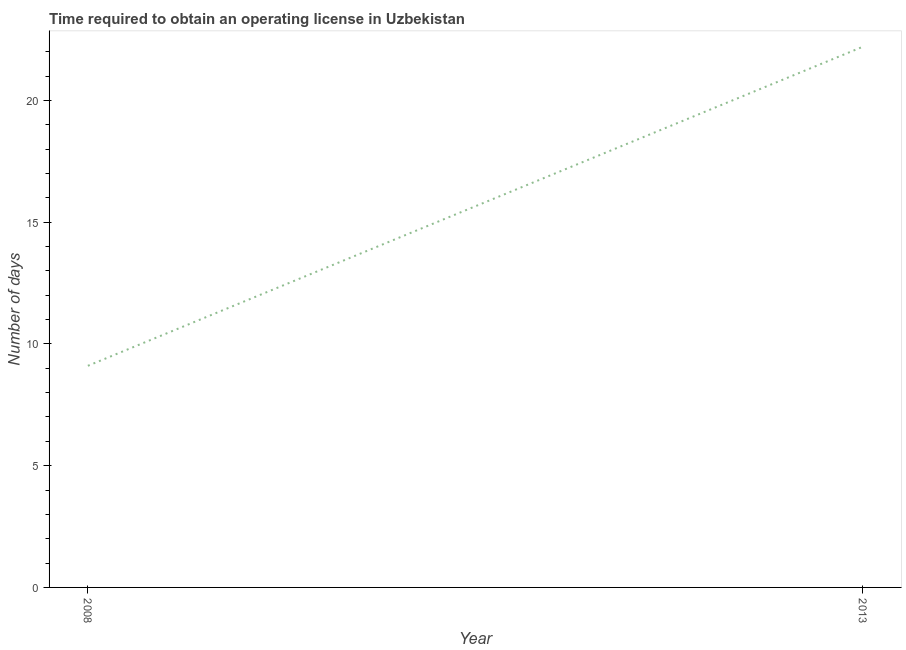What is the number of days to obtain operating license in 2008?
Offer a terse response. 9.1. Across all years, what is the maximum number of days to obtain operating license?
Your answer should be compact. 22.2. What is the sum of the number of days to obtain operating license?
Offer a terse response. 31.3. What is the difference between the number of days to obtain operating license in 2008 and 2013?
Offer a terse response. -13.1. What is the average number of days to obtain operating license per year?
Offer a very short reply. 15.65. What is the median number of days to obtain operating license?
Make the answer very short. 15.65. In how many years, is the number of days to obtain operating license greater than 4 days?
Keep it short and to the point. 2. Do a majority of the years between 2013 and 2008 (inclusive) have number of days to obtain operating license greater than 7 days?
Give a very brief answer. No. What is the ratio of the number of days to obtain operating license in 2008 to that in 2013?
Your answer should be very brief. 0.41. In how many years, is the number of days to obtain operating license greater than the average number of days to obtain operating license taken over all years?
Offer a very short reply. 1. Does the number of days to obtain operating license monotonically increase over the years?
Ensure brevity in your answer.  Yes. What is the difference between two consecutive major ticks on the Y-axis?
Offer a very short reply. 5. Are the values on the major ticks of Y-axis written in scientific E-notation?
Provide a short and direct response. No. Does the graph contain grids?
Your response must be concise. No. What is the title of the graph?
Give a very brief answer. Time required to obtain an operating license in Uzbekistan. What is the label or title of the X-axis?
Your answer should be very brief. Year. What is the label or title of the Y-axis?
Provide a succinct answer. Number of days. What is the ratio of the Number of days in 2008 to that in 2013?
Provide a short and direct response. 0.41. 